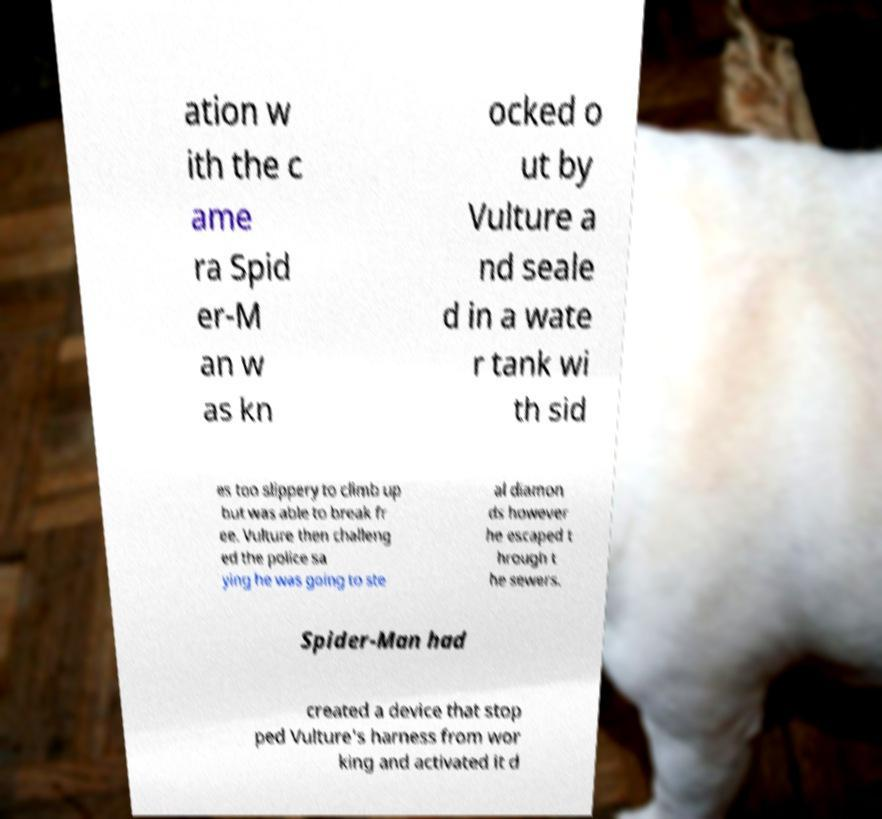Can you accurately transcribe the text from the provided image for me? ation w ith the c ame ra Spid er-M an w as kn ocked o ut by Vulture a nd seale d in a wate r tank wi th sid es too slippery to climb up but was able to break fr ee. Vulture then challeng ed the police sa ying he was going to ste al diamon ds however he escaped t hrough t he sewers. Spider-Man had created a device that stop ped Vulture's harness from wor king and activated it d 